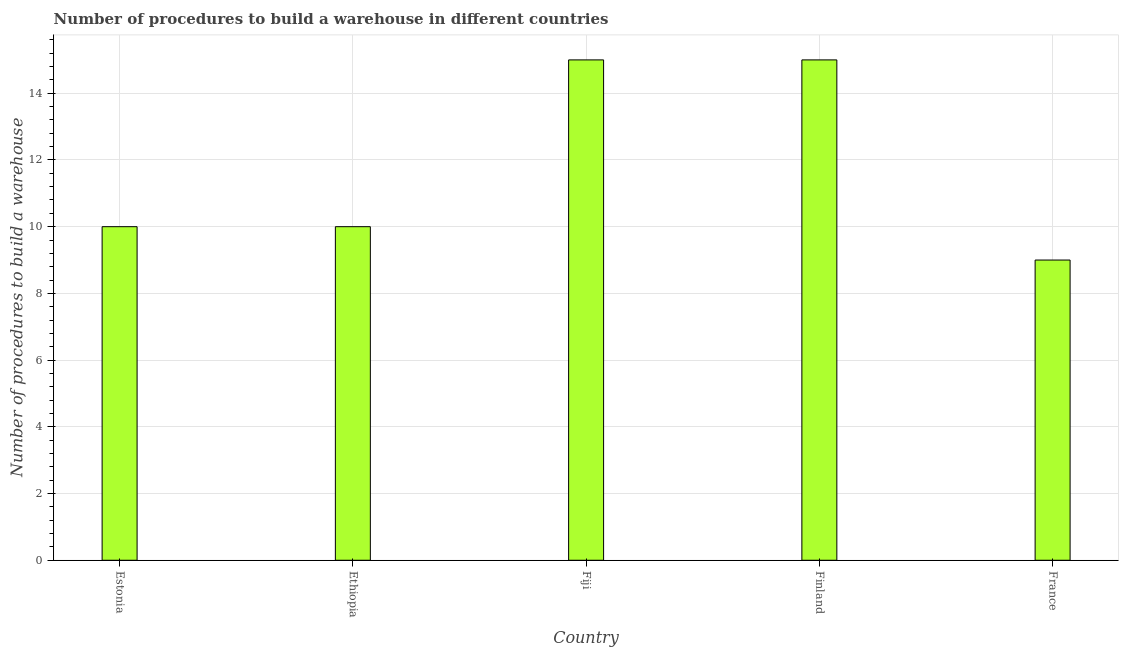Does the graph contain any zero values?
Ensure brevity in your answer.  No. Does the graph contain grids?
Provide a succinct answer. Yes. What is the title of the graph?
Keep it short and to the point. Number of procedures to build a warehouse in different countries. What is the label or title of the X-axis?
Keep it short and to the point. Country. What is the label or title of the Y-axis?
Offer a terse response. Number of procedures to build a warehouse. What is the number of procedures to build a warehouse in Fiji?
Your answer should be very brief. 15. In which country was the number of procedures to build a warehouse maximum?
Offer a terse response. Fiji. In which country was the number of procedures to build a warehouse minimum?
Give a very brief answer. France. What is the sum of the number of procedures to build a warehouse?
Your response must be concise. 59. What is the difference between the number of procedures to build a warehouse in Ethiopia and Finland?
Your answer should be compact. -5. What is the median number of procedures to build a warehouse?
Your answer should be compact. 10. What is the ratio of the number of procedures to build a warehouse in Ethiopia to that in Finland?
Your answer should be very brief. 0.67. Is the number of procedures to build a warehouse in Estonia less than that in Fiji?
Provide a succinct answer. Yes. Is the difference between the number of procedures to build a warehouse in Ethiopia and Finland greater than the difference between any two countries?
Keep it short and to the point. No. Is the sum of the number of procedures to build a warehouse in Ethiopia and France greater than the maximum number of procedures to build a warehouse across all countries?
Offer a terse response. Yes. How many bars are there?
Give a very brief answer. 5. Are all the bars in the graph horizontal?
Offer a very short reply. No. What is the difference between two consecutive major ticks on the Y-axis?
Your answer should be compact. 2. Are the values on the major ticks of Y-axis written in scientific E-notation?
Offer a very short reply. No. What is the Number of procedures to build a warehouse in Ethiopia?
Provide a succinct answer. 10. What is the Number of procedures to build a warehouse of Fiji?
Provide a short and direct response. 15. What is the Number of procedures to build a warehouse in Finland?
Your answer should be compact. 15. What is the Number of procedures to build a warehouse in France?
Give a very brief answer. 9. What is the difference between the Number of procedures to build a warehouse in Estonia and Ethiopia?
Offer a terse response. 0. What is the difference between the Number of procedures to build a warehouse in Estonia and Fiji?
Keep it short and to the point. -5. What is the difference between the Number of procedures to build a warehouse in Estonia and Finland?
Ensure brevity in your answer.  -5. What is the difference between the Number of procedures to build a warehouse in Estonia and France?
Give a very brief answer. 1. What is the difference between the Number of procedures to build a warehouse in Fiji and Finland?
Your answer should be very brief. 0. What is the difference between the Number of procedures to build a warehouse in Finland and France?
Offer a very short reply. 6. What is the ratio of the Number of procedures to build a warehouse in Estonia to that in Ethiopia?
Your response must be concise. 1. What is the ratio of the Number of procedures to build a warehouse in Estonia to that in Fiji?
Provide a short and direct response. 0.67. What is the ratio of the Number of procedures to build a warehouse in Estonia to that in Finland?
Keep it short and to the point. 0.67. What is the ratio of the Number of procedures to build a warehouse in Estonia to that in France?
Give a very brief answer. 1.11. What is the ratio of the Number of procedures to build a warehouse in Ethiopia to that in Fiji?
Your answer should be very brief. 0.67. What is the ratio of the Number of procedures to build a warehouse in Ethiopia to that in Finland?
Ensure brevity in your answer.  0.67. What is the ratio of the Number of procedures to build a warehouse in Ethiopia to that in France?
Provide a short and direct response. 1.11. What is the ratio of the Number of procedures to build a warehouse in Fiji to that in Finland?
Provide a succinct answer. 1. What is the ratio of the Number of procedures to build a warehouse in Fiji to that in France?
Offer a terse response. 1.67. What is the ratio of the Number of procedures to build a warehouse in Finland to that in France?
Your response must be concise. 1.67. 